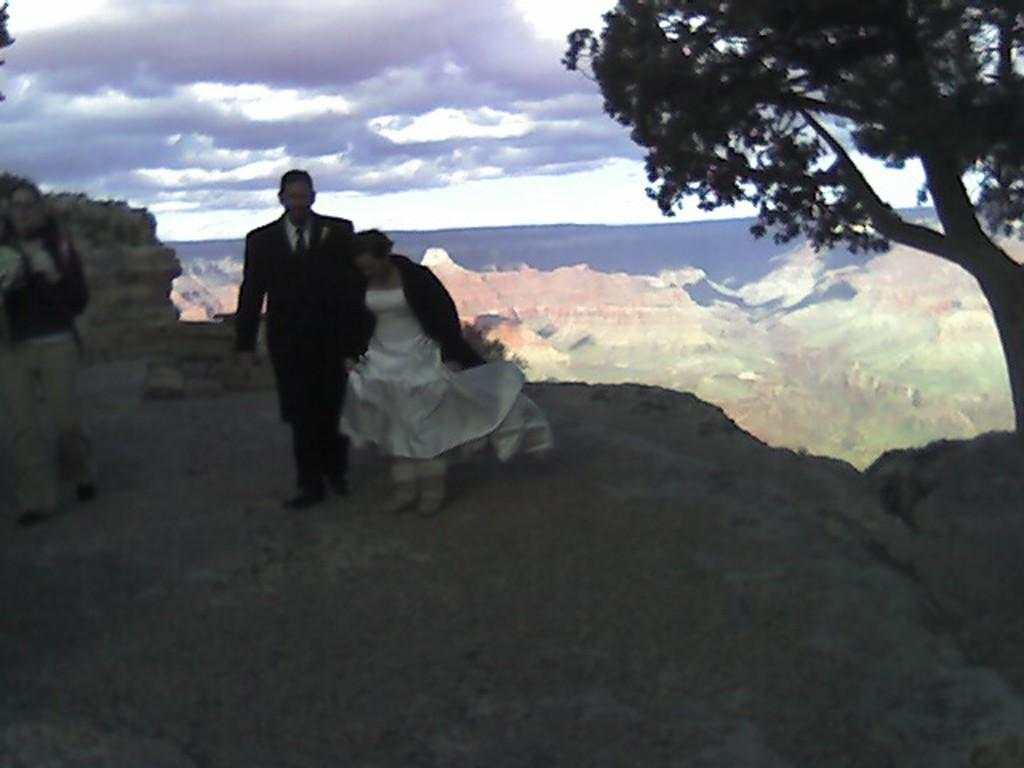How many people are in the image? There are three persons in the image. What else can be seen in the image besides the people? There is a tree in the image. What is visible in the background of the image? The sky is visible in the background of the image. Can you describe the sky in the image? The sky has heavy clouds. Reasoning: Let' Let's think step by step in order to produce the conversation. We start by identifying the main subject of the image, which is the three persons. Then, we expand the conversation to include other elements in the image, such as the tree and the sky. We ensure that each question is focused on a specific detail that can be answered definitively with the provided facts. Absurd Question/Answer: What type of furniture can be seen in the image? There is no furniture present in the image. How does the rabbit express its anger in the image? There is no rabbit or expression of anger present in the image. What type of furniture can be seen in the image? There is no furniture present in the image. How does the rabbit express its anger in the image? There is no rabbit or expression of anger present in the image. 